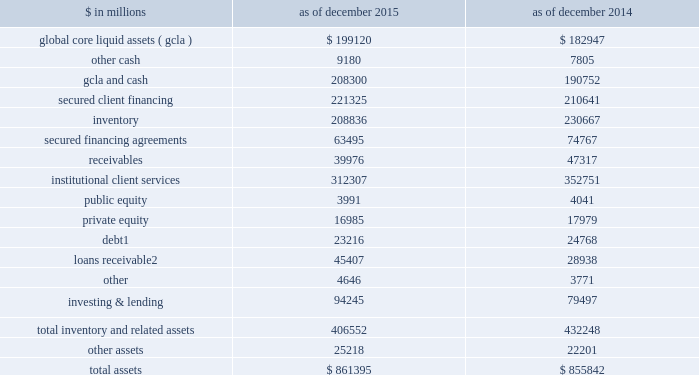The goldman sachs group , inc .
And subsidiaries management 2019s discussion and analysis scenario analyses .
We conduct various scenario analyses including as part of the comprehensive capital analysis and review ( ccar ) and dodd-frank act stress tests ( dfast ) , as well as our resolution and recovery planning .
See 201cequity capital management and regulatory capital 2014 equity capital management 201d below for further information .
These scenarios cover short-term and long- term time horizons using various macroeconomic and firm- specific assumptions , based on a range of economic scenarios .
We use these analyses to assist us in developing our longer-term balance sheet management strategy , including the level and composition of assets , funding and equity capital .
Additionally , these analyses help us develop approaches for maintaining appropriate funding , liquidity and capital across a variety of situations , including a severely stressed environment .
Balance sheet allocation in addition to preparing our consolidated statements of financial condition in accordance with u.s .
Gaap , we prepare a balance sheet that generally allocates assets to our businesses , which is a non-gaap presentation and may not be comparable to similar non-gaap presentations used by other companies .
We believe that presenting our assets on this basis is meaningful because it is consistent with the way management views and manages risks associated with the firm 2019s assets and better enables investors to assess the liquidity of the firm 2019s assets .
The table below presents our balance sheet allocation. .
Includes $ 17.29 billion and $ 18.24 billion as of december 2015 and december 2014 , respectively , of direct loans primarily extended to corporate and private wealth management clients that are accounted for at fair value .
See note 9 to the consolidated financial statements for further information about loans receivable .
The following is a description of the captions in the table above : 2030 global core liquid assets and cash .
We maintain liquidity to meet a broad range of potential cash outflows and collateral needs in a stressed environment .
See 201cliquidity risk management 201d below for details on the composition and sizing of our 201cglobal core liquid assets 201d ( gcla ) .
In addition to our gcla , we maintain other operating cash balances , primarily for use in specific currencies , entities , or jurisdictions where we do not have immediate access to parent company liquidity .
2030 secured client financing .
We provide collateralized financing for client positions , including margin loans secured by client collateral , securities borrowed , and resale agreements primarily collateralized by government obligations .
As a result of client activities , we are required to segregate cash and securities to satisfy regulatory requirements .
Our secured client financing arrangements , which are generally short-term , are accounted for at fair value or at amounts that approximate fair value , and include daily margin requirements to mitigate counterparty credit risk .
2030 institutional client services .
In institutional client services , we maintain inventory positions to facilitate market making in fixed income , equity , currency and commodity products .
Additionally , as part of market- making activities , we enter into resale or securities borrowing arrangements to obtain securities which we can use to cover transactions in which we or our clients have sold securities that have not yet been purchased .
The receivables in institutional client services primarily relate to securities transactions .
2030 investing & lending .
In investing & lending , we make investments and originate loans to provide financing to clients .
These investments and loans are typically longer- term in nature .
We make investments , directly and indirectly through funds and separate accounts that we manage , in debt securities , loans , public and private equity securities , real estate entities and other investments .
2030 other assets .
Other assets are generally less liquid , non- financial assets , including property , leasehold improvements and equipment , goodwill and identifiable intangible assets , income tax-related receivables , equity- method investments , assets classified as held for sale and miscellaneous receivables .
68 goldman sachs 2015 form 10-k .
How is cash flow from operating activities affected by the change in receivables from 2014 to 2015? 
Computations: (47317 - 39976)
Answer: 7341.0. 